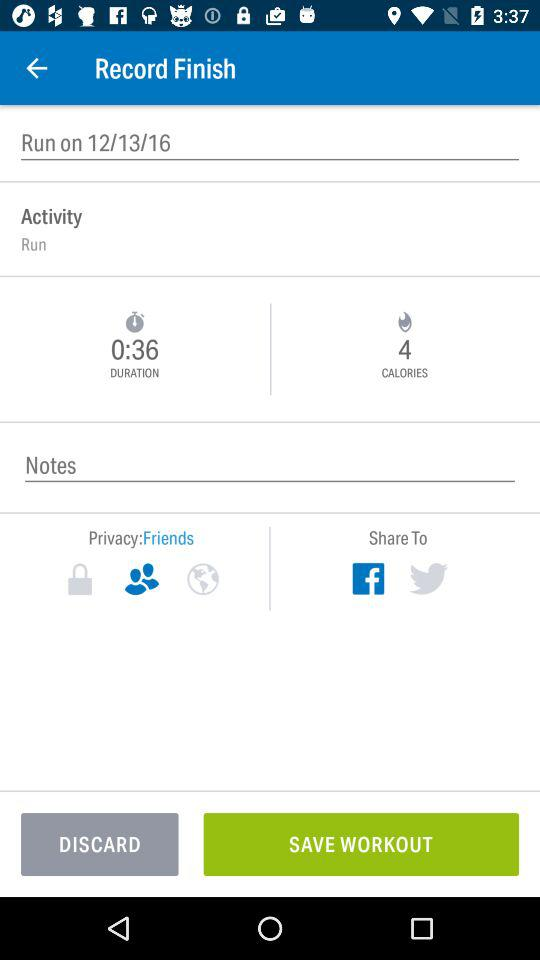How many calories did I burn?
Answer the question using a single word or phrase. 4 